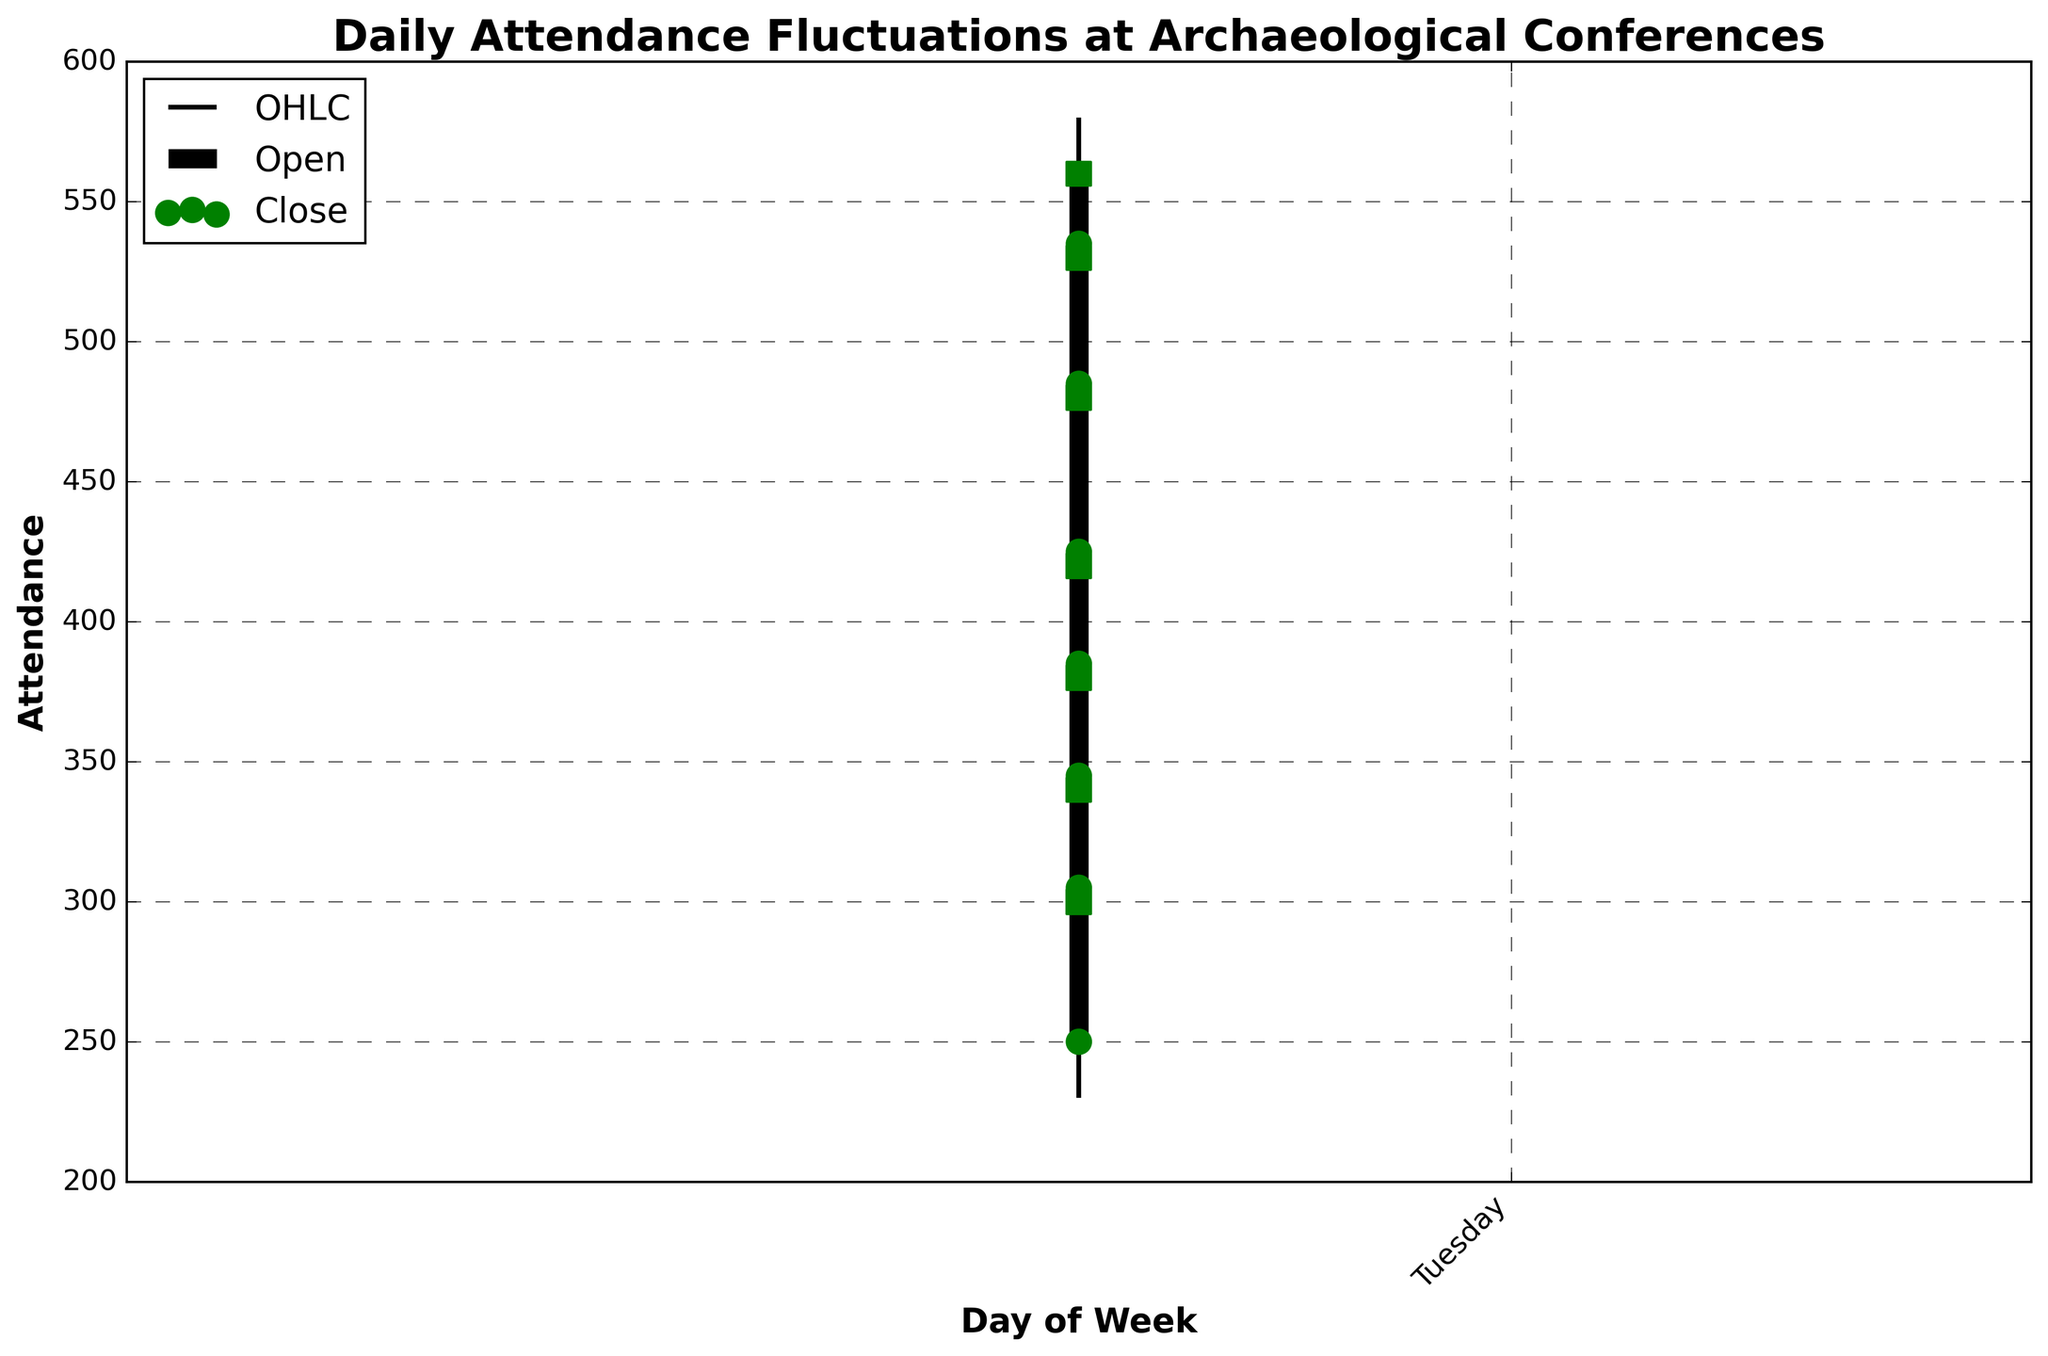What is the title of the chart? The title of the chart is displayed at the top. It reads "Daily Attendance Fluctuations at Archaeological Conferences."
Answer: Daily Attendance Fluctuations at Archaeological Conferences How is the attendance represented for each day? Each day has four key attendance figures represented: the opening, high, low, and closing attendances. These are shown with vertical lines, circles, and squares.
Answer: Open, High, Low, Close What is the highest attendance recorded on Saturday? The vertical line representing Saturday shows the highest point reached, which is labeled at 550.
Answer: 550 Which day had the lowest opening attendance? The opening attendance is marked by circles, and the lowest circle appears on Monday at the 250 mark.
Answer: Monday Which days have their closing attendance higher than the opening attendance? Green colors indicate days where the closing attendance (squares) is higher than the opening attendance (circles). This is true for Monday, Tuesday, Wednesday, Thursday, Friday, Saturday, and Sunday.
Answer: Monday, Tuesday, Wednesday, Thursday, Friday, Saturday, Sunday What is the difference between the highest and lowest attendance on Friday? The highest attendance on Friday is 500 and the lowest is 410. Subtracting these values gives 90.
Answer: 90 On which day did the closing attendance most significantly exceed the opening attendance? Calculate the difference between closing and opening attendance for each day. The largest difference is on Sunday where the closing attendance is 560 and the opening is 535, giving a difference of 25.
Answer: Sunday What is the average closing attendance for the week? Sum the closing attendances: 300 + 340 + 380 + 420 + 480 + 530 + 560 = 3010. Divide this by 7 days: 3010 / 7 ≈ 430.
Answer: Approximately 430 Compare the attendance fluctuations on Thursday and Saturday. Which day has greater variability? Variability can be observed by the length of the vertical lines representing the high and low points. Thursday's range is 450 - 370 = 80, and Saturday's range is 550 - 470 = 80. Both have the same variability.
Answer: Both have the same variability What is the trend in closing attendance over the week? Inspect the closing attendance values from Monday to Sunday (300, 340, 380, 420, 480, 530, 560). There is a consistent increase each day.
Answer: Increasing 